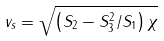<formula> <loc_0><loc_0><loc_500><loc_500>v _ { s } = \sqrt { \left ( S _ { 2 } - S _ { 3 } ^ { 2 } / S _ { 1 } \right ) \chi } \,</formula> 